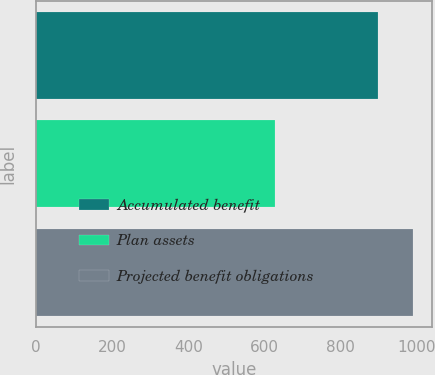Convert chart to OTSL. <chart><loc_0><loc_0><loc_500><loc_500><bar_chart><fcel>Accumulated benefit<fcel>Plan assets<fcel>Projected benefit obligations<nl><fcel>899<fcel>627<fcel>990<nl></chart> 